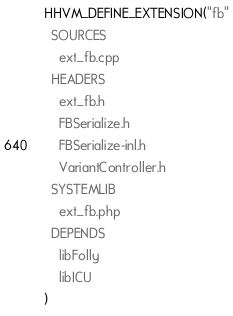<code> <loc_0><loc_0><loc_500><loc_500><_CMake_>HHVM_DEFINE_EXTENSION("fb"
  SOURCES
    ext_fb.cpp
  HEADERS
    ext_fb.h
    FBSerialize.h
    FBSerialize-inl.h
    VariantController.h
  SYSTEMLIB
    ext_fb.php
  DEPENDS
    libFolly
    libICU
)
</code> 